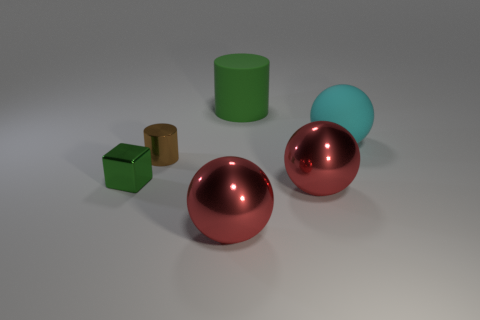There is a cube that is the same color as the large matte cylinder; what material is it?
Your answer should be compact. Metal. Is the matte cylinder the same color as the small cube?
Ensure brevity in your answer.  Yes. There is a big red object that is on the left side of the big green object; is its shape the same as the large red metallic thing on the right side of the green cylinder?
Your response must be concise. Yes. There is a small object that is the same shape as the big green matte thing; what is it made of?
Offer a very short reply. Metal. What material is the small thing behind the green object that is left of the big red sphere left of the matte cylinder?
Offer a terse response. Metal. There is a block that is the same material as the tiny brown cylinder; what size is it?
Keep it short and to the point. Small. Is there any other thing of the same color as the large matte ball?
Offer a very short reply. No. There is a small shiny object that is in front of the tiny brown metallic cylinder; does it have the same color as the cylinder behind the small brown thing?
Ensure brevity in your answer.  Yes. There is a large rubber thing behind the cyan rubber object; what color is it?
Make the answer very short. Green. Does the rubber object that is right of the green matte cylinder have the same size as the tiny brown shiny cylinder?
Give a very brief answer. No. 